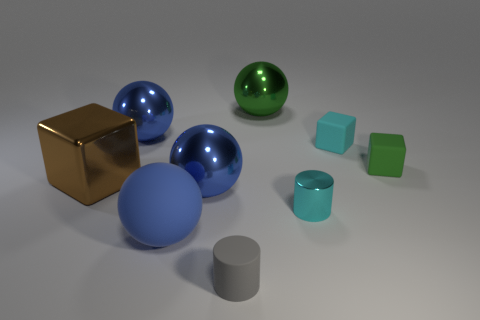Subtract all purple blocks. How many blue balls are left? 3 Subtract all blocks. How many objects are left? 6 Subtract all tiny metallic objects. Subtract all small rubber things. How many objects are left? 5 Add 5 large blue metallic things. How many large blue metallic things are left? 7 Add 8 brown shiny things. How many brown shiny things exist? 9 Subtract 0 blue cylinders. How many objects are left? 9 